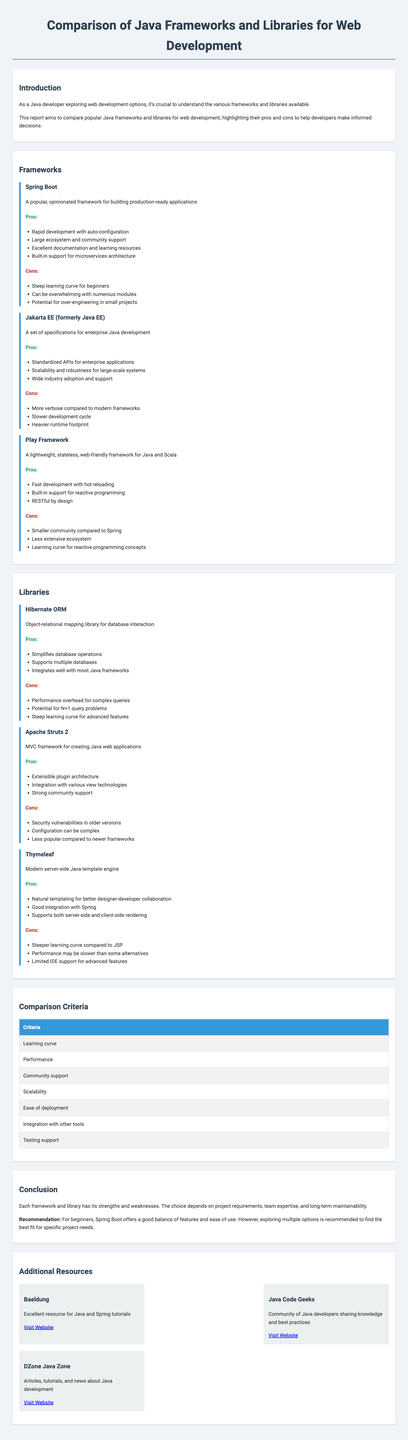What is the title of the report? The title of the report is stated at the beginning and provides the main subject of the document.
Answer: Comparison of Java Frameworks and Libraries for Web Development Which framework offers rapid development with auto-configuration? The report lists benefits under each framework section, and Spring Boot is highlighted for its rapid development capabilities.
Answer: Spring Boot What is one con of Hibernate ORM? The document details the drawbacks of Hibernate ORM, mentioning its performance issues as one of the cons.
Answer: Performance overhead for complex queries Which library is a modern server-side Java template engine? The description of libraries refers to Thymeleaf as the modern template engine in the context provided.
Answer: Thymeleaf What is the learning curve classification for Spring Boot? The report mentions the learning curve as a specific drawback, particularly highlighting this aspect for beginners.
Answer: Steep learning curve for beginners How many frameworks are compared in the report? By counting the number of frameworks listed in the frameworks section, we can determine this numerical detail.
Answer: Three What is a significant advantage of Jakarta EE? The pros of Jakarta EE include standardized APIs, which significantly benefits enterprise applications.
Answer: Standardized APIs for enterprise applications What does the report recommend for beginners? The recommendation section advises beginners on an appropriate framework considering ease of use and features.
Answer: Spring Boot Which additional resource focuses on Java development best practices? The additional resources section lists various websites, highlighting one community as sharing best practices for developers.
Answer: Java Code Geeks 